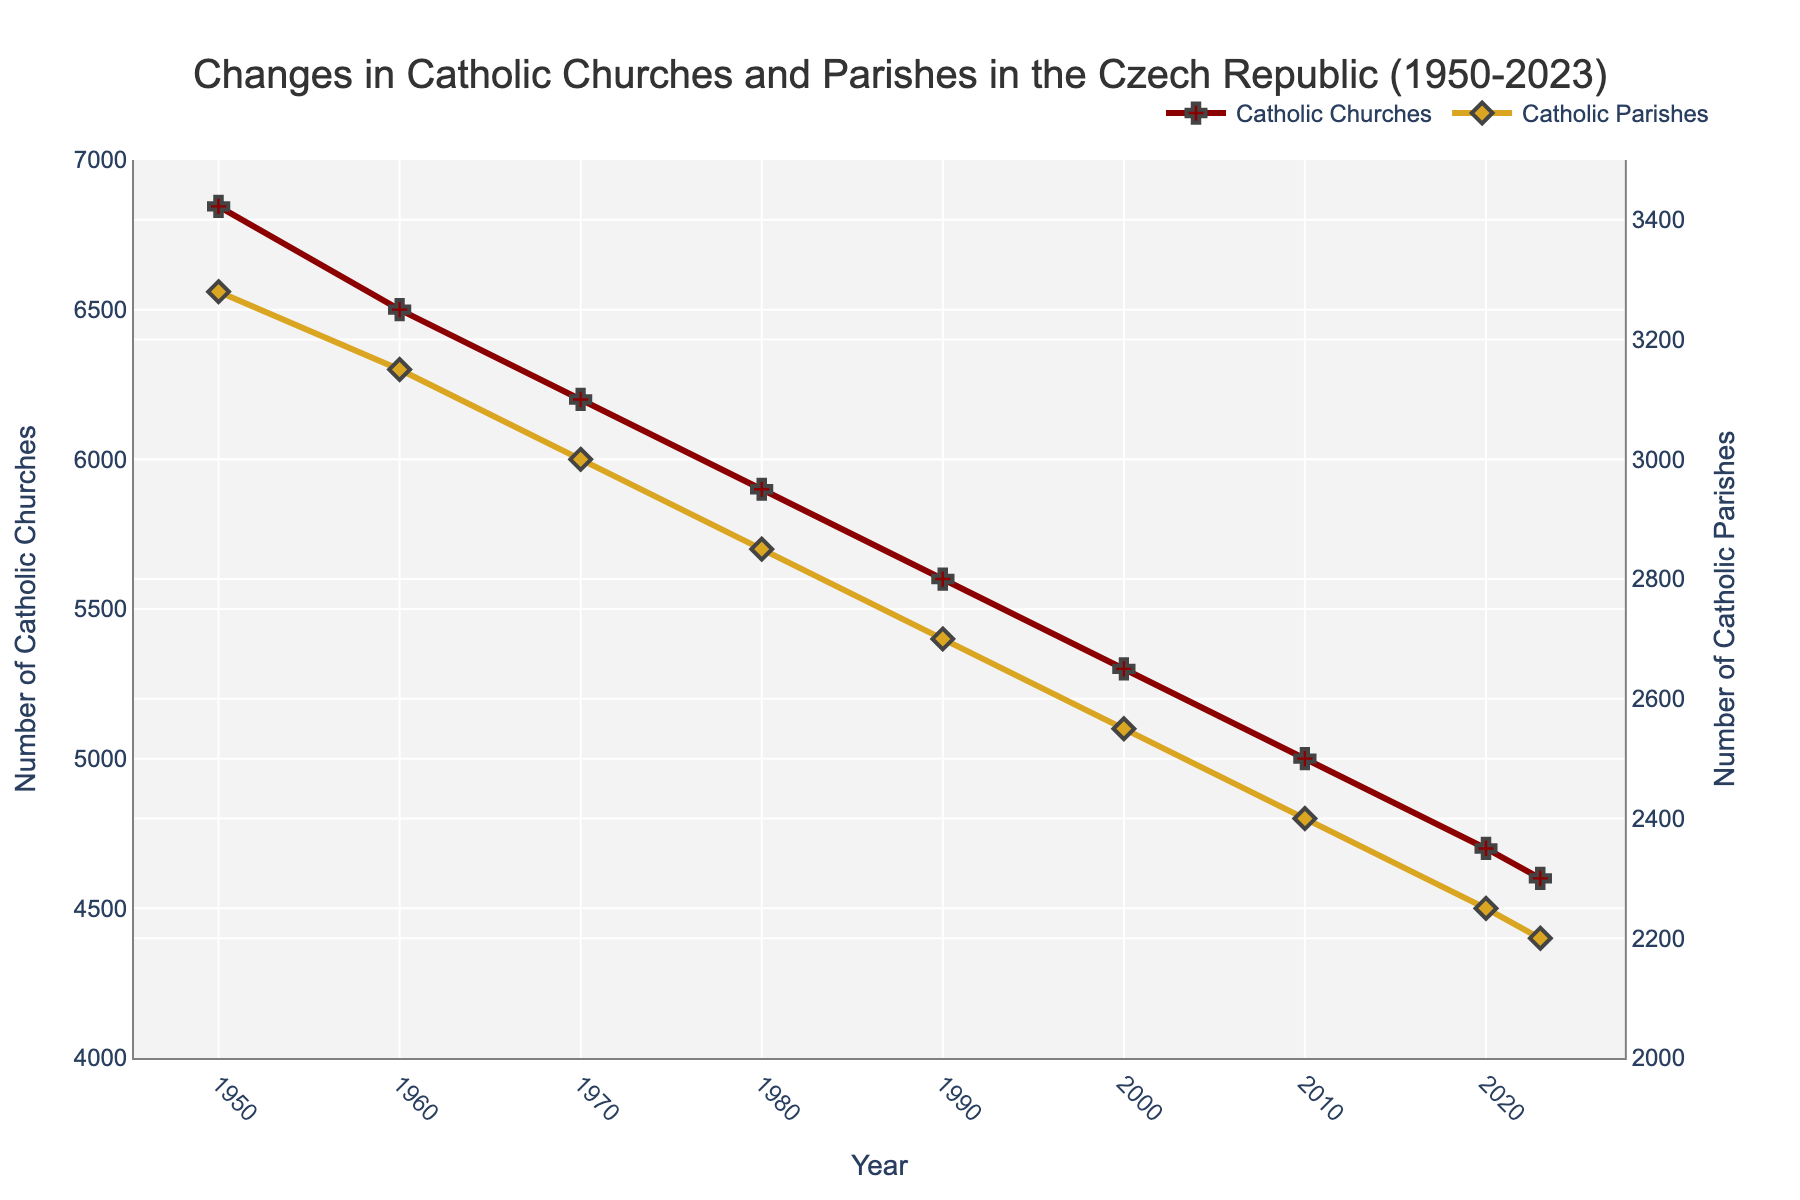What is the general trend in the number of Catholic churches from 1950 to 2023? The general trend can be observed by looking at the line representing Catholic churches on the graph. It shows a consistent decline over the years from about 6845 in 1950 to 4600 in 2023.
Answer: Decline What is the number of Catholic parishes in 2010, and how does it compare to the number in 2023? Check the values on the plot for the years 2010 and 2023 for Catholic parishes. In 2010, it is 2400, and in 2023, it is 2200. Comparing these values shows a decrease of 200 parishes.
Answer: 200 parishes decrease How many Catholic churches were there in 2000, and how have they changed by 2020? Look at the values for Catholic churches in 2000 and 2020. In 2000, there were 5300 churches, while in 2020, there were 4700. Thus, there is a decrease of 600 churches.
Answer: 600 churches decrease What is the rate of change in the number of Catholic parishes from 1950 to 1990? Calculate the difference in the number of Catholic parishes from 1950 to 1990 and divide by the number of years. In 1950, there were 3280 parishes, and in 1990, there were 2700. The change is 3280 - 2700 = 580. There are 40 years between 1950 and 1990, so the rate is 580/40 = 14.5 parishes per year.
Answer: 14.5 parishes per year In which decade did the number of Catholic churches see the steepest decline? Compare the slopes of the line segments between each decade for Catholic churches. The steepest decline appears between 2000 and 2010, where the decrease is most rapid.
Answer: 2000-2010 What visual attributes are used to distinguish between Catholic churches and Catholic parishes on the graph? The graph uses different colored lines and markers for each. Catholic churches are represented by a red line with cross markers, and Catholic parishes are represented by a gold line with diamond markers.
Answer: Different colors and markers Which year had the closest number of Catholic churches and parishes? Examine the points where the lines representing Catholic churches and parishes are closest. In 2023, the numbers for churches are 4600 and parishes are 2200, with the smallest gap compared to other years.
Answer: 2023 How has the number of Catholic churches changed from 1980 to 2023 proportionally? First, find the number of churches in 1980 and 2023. In 1980, it was 5900, and in 2023, it is 4600. The change is 5900 - 4600 = 1300. Divide this change by the 1980 value to find the proportion: 1300/5900 ≈ 0.22 or 22%.
Answer: 22% decrease 